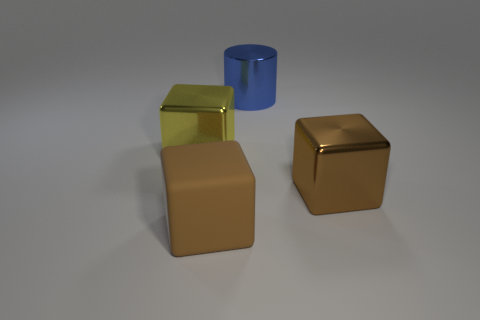Subtract all rubber cubes. How many cubes are left? 2 Subtract all red cylinders. How many brown blocks are left? 2 Add 4 small cyan matte cubes. How many objects exist? 8 Subtract 1 cylinders. How many cylinders are left? 0 Subtract all cylinders. How many objects are left? 3 Subtract all yellow shiny cubes. Subtract all big brown shiny blocks. How many objects are left? 2 Add 1 cylinders. How many cylinders are left? 2 Add 2 blocks. How many blocks exist? 5 Subtract 0 purple spheres. How many objects are left? 4 Subtract all purple blocks. Subtract all brown cylinders. How many blocks are left? 3 